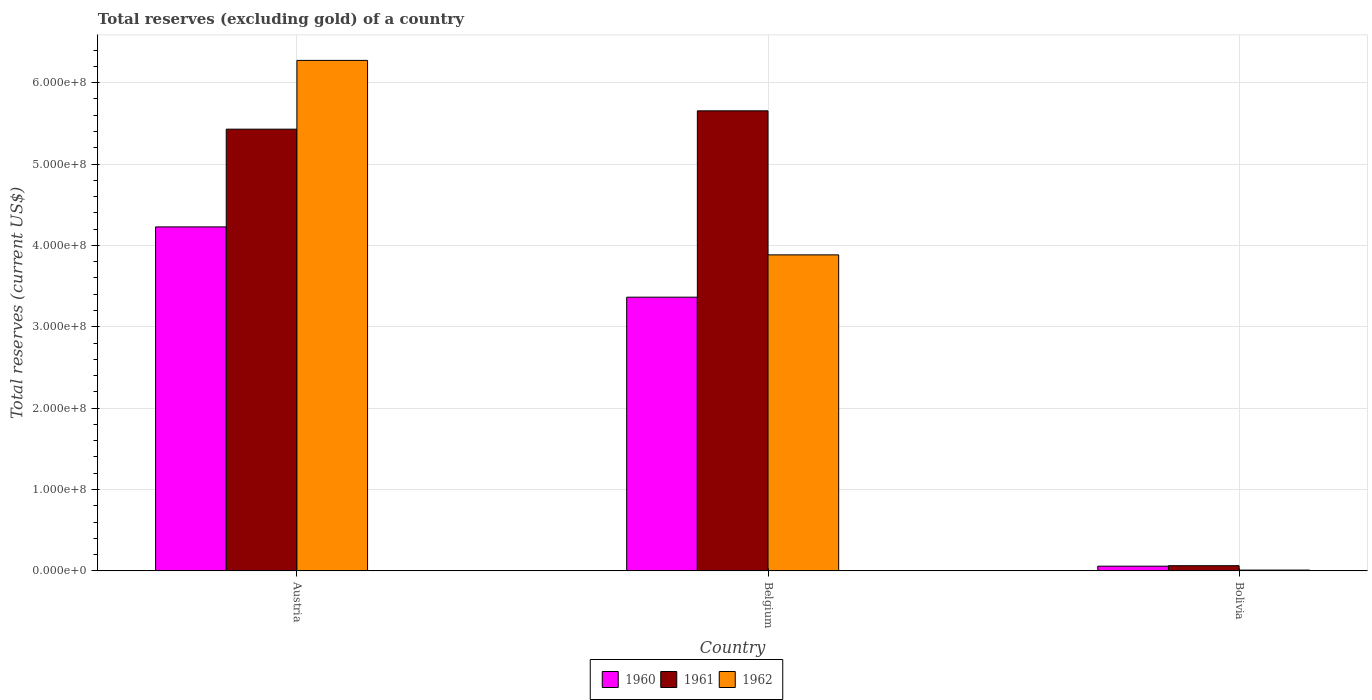How many different coloured bars are there?
Provide a short and direct response. 3. In how many cases, is the number of bars for a given country not equal to the number of legend labels?
Make the answer very short. 0. What is the total reserves (excluding gold) in 1960 in Bolivia?
Ensure brevity in your answer.  5.80e+06. Across all countries, what is the maximum total reserves (excluding gold) in 1960?
Provide a succinct answer. 4.23e+08. Across all countries, what is the minimum total reserves (excluding gold) in 1960?
Your answer should be very brief. 5.80e+06. In which country was the total reserves (excluding gold) in 1961 maximum?
Keep it short and to the point. Belgium. What is the total total reserves (excluding gold) in 1961 in the graph?
Make the answer very short. 1.11e+09. What is the difference between the total reserves (excluding gold) in 1961 in Austria and that in Belgium?
Your response must be concise. -2.25e+07. What is the difference between the total reserves (excluding gold) in 1961 in Bolivia and the total reserves (excluding gold) in 1962 in Belgium?
Keep it short and to the point. -3.82e+08. What is the average total reserves (excluding gold) in 1961 per country?
Offer a terse response. 3.72e+08. What is the difference between the total reserves (excluding gold) of/in 1960 and total reserves (excluding gold) of/in 1961 in Austria?
Keep it short and to the point. -1.20e+08. In how many countries, is the total reserves (excluding gold) in 1961 greater than 100000000 US$?
Offer a terse response. 2. What is the ratio of the total reserves (excluding gold) in 1962 in Austria to that in Bolivia?
Make the answer very short. 627.38. Is the total reserves (excluding gold) in 1960 in Belgium less than that in Bolivia?
Offer a terse response. No. What is the difference between the highest and the second highest total reserves (excluding gold) in 1961?
Offer a terse response. -5.36e+08. What is the difference between the highest and the lowest total reserves (excluding gold) in 1962?
Offer a very short reply. 6.26e+08. Are all the bars in the graph horizontal?
Ensure brevity in your answer.  No. What is the difference between two consecutive major ticks on the Y-axis?
Offer a very short reply. 1.00e+08. Where does the legend appear in the graph?
Offer a terse response. Bottom center. How many legend labels are there?
Ensure brevity in your answer.  3. What is the title of the graph?
Ensure brevity in your answer.  Total reserves (excluding gold) of a country. What is the label or title of the Y-axis?
Offer a very short reply. Total reserves (current US$). What is the Total reserves (current US$) in 1960 in Austria?
Keep it short and to the point. 4.23e+08. What is the Total reserves (current US$) in 1961 in Austria?
Provide a succinct answer. 5.43e+08. What is the Total reserves (current US$) in 1962 in Austria?
Ensure brevity in your answer.  6.27e+08. What is the Total reserves (current US$) in 1960 in Belgium?
Offer a terse response. 3.36e+08. What is the Total reserves (current US$) in 1961 in Belgium?
Provide a short and direct response. 5.65e+08. What is the Total reserves (current US$) of 1962 in Belgium?
Your answer should be compact. 3.88e+08. What is the Total reserves (current US$) of 1960 in Bolivia?
Your answer should be compact. 5.80e+06. What is the Total reserves (current US$) of 1961 in Bolivia?
Offer a very short reply. 6.40e+06. Across all countries, what is the maximum Total reserves (current US$) of 1960?
Give a very brief answer. 4.23e+08. Across all countries, what is the maximum Total reserves (current US$) in 1961?
Ensure brevity in your answer.  5.65e+08. Across all countries, what is the maximum Total reserves (current US$) in 1962?
Offer a very short reply. 6.27e+08. Across all countries, what is the minimum Total reserves (current US$) of 1960?
Your answer should be very brief. 5.80e+06. Across all countries, what is the minimum Total reserves (current US$) of 1961?
Make the answer very short. 6.40e+06. What is the total Total reserves (current US$) of 1960 in the graph?
Offer a very short reply. 7.65e+08. What is the total Total reserves (current US$) of 1961 in the graph?
Your response must be concise. 1.11e+09. What is the total Total reserves (current US$) of 1962 in the graph?
Make the answer very short. 1.02e+09. What is the difference between the Total reserves (current US$) in 1960 in Austria and that in Belgium?
Your answer should be very brief. 8.64e+07. What is the difference between the Total reserves (current US$) in 1961 in Austria and that in Belgium?
Provide a succinct answer. -2.25e+07. What is the difference between the Total reserves (current US$) of 1962 in Austria and that in Belgium?
Offer a terse response. 2.39e+08. What is the difference between the Total reserves (current US$) in 1960 in Austria and that in Bolivia?
Your answer should be very brief. 4.17e+08. What is the difference between the Total reserves (current US$) of 1961 in Austria and that in Bolivia?
Make the answer very short. 5.36e+08. What is the difference between the Total reserves (current US$) in 1962 in Austria and that in Bolivia?
Your response must be concise. 6.26e+08. What is the difference between the Total reserves (current US$) in 1960 in Belgium and that in Bolivia?
Make the answer very short. 3.31e+08. What is the difference between the Total reserves (current US$) of 1961 in Belgium and that in Bolivia?
Provide a succinct answer. 5.59e+08. What is the difference between the Total reserves (current US$) in 1962 in Belgium and that in Bolivia?
Give a very brief answer. 3.87e+08. What is the difference between the Total reserves (current US$) in 1960 in Austria and the Total reserves (current US$) in 1961 in Belgium?
Make the answer very short. -1.43e+08. What is the difference between the Total reserves (current US$) in 1960 in Austria and the Total reserves (current US$) in 1962 in Belgium?
Give a very brief answer. 3.44e+07. What is the difference between the Total reserves (current US$) of 1961 in Austria and the Total reserves (current US$) of 1962 in Belgium?
Give a very brief answer. 1.54e+08. What is the difference between the Total reserves (current US$) in 1960 in Austria and the Total reserves (current US$) in 1961 in Bolivia?
Provide a succinct answer. 4.16e+08. What is the difference between the Total reserves (current US$) in 1960 in Austria and the Total reserves (current US$) in 1962 in Bolivia?
Your response must be concise. 4.22e+08. What is the difference between the Total reserves (current US$) of 1961 in Austria and the Total reserves (current US$) of 1962 in Bolivia?
Provide a succinct answer. 5.42e+08. What is the difference between the Total reserves (current US$) in 1960 in Belgium and the Total reserves (current US$) in 1961 in Bolivia?
Give a very brief answer. 3.30e+08. What is the difference between the Total reserves (current US$) in 1960 in Belgium and the Total reserves (current US$) in 1962 in Bolivia?
Offer a very short reply. 3.35e+08. What is the difference between the Total reserves (current US$) in 1961 in Belgium and the Total reserves (current US$) in 1962 in Bolivia?
Make the answer very short. 5.64e+08. What is the average Total reserves (current US$) of 1960 per country?
Provide a succinct answer. 2.55e+08. What is the average Total reserves (current US$) in 1961 per country?
Your answer should be very brief. 3.72e+08. What is the average Total reserves (current US$) of 1962 per country?
Your answer should be very brief. 3.39e+08. What is the difference between the Total reserves (current US$) in 1960 and Total reserves (current US$) in 1961 in Austria?
Your answer should be compact. -1.20e+08. What is the difference between the Total reserves (current US$) of 1960 and Total reserves (current US$) of 1962 in Austria?
Offer a very short reply. -2.05e+08. What is the difference between the Total reserves (current US$) of 1961 and Total reserves (current US$) of 1962 in Austria?
Your answer should be very brief. -8.45e+07. What is the difference between the Total reserves (current US$) of 1960 and Total reserves (current US$) of 1961 in Belgium?
Offer a terse response. -2.29e+08. What is the difference between the Total reserves (current US$) of 1960 and Total reserves (current US$) of 1962 in Belgium?
Keep it short and to the point. -5.20e+07. What is the difference between the Total reserves (current US$) of 1961 and Total reserves (current US$) of 1962 in Belgium?
Ensure brevity in your answer.  1.77e+08. What is the difference between the Total reserves (current US$) of 1960 and Total reserves (current US$) of 1961 in Bolivia?
Provide a short and direct response. -6.00e+05. What is the difference between the Total reserves (current US$) of 1960 and Total reserves (current US$) of 1962 in Bolivia?
Give a very brief answer. 4.80e+06. What is the difference between the Total reserves (current US$) in 1961 and Total reserves (current US$) in 1962 in Bolivia?
Offer a very short reply. 5.40e+06. What is the ratio of the Total reserves (current US$) in 1960 in Austria to that in Belgium?
Keep it short and to the point. 1.26. What is the ratio of the Total reserves (current US$) of 1961 in Austria to that in Belgium?
Ensure brevity in your answer.  0.96. What is the ratio of the Total reserves (current US$) in 1962 in Austria to that in Belgium?
Your answer should be very brief. 1.62. What is the ratio of the Total reserves (current US$) in 1960 in Austria to that in Bolivia?
Give a very brief answer. 72.89. What is the ratio of the Total reserves (current US$) of 1961 in Austria to that in Bolivia?
Make the answer very short. 84.82. What is the ratio of the Total reserves (current US$) in 1962 in Austria to that in Bolivia?
Offer a very short reply. 627.38. What is the ratio of the Total reserves (current US$) in 1960 in Belgium to that in Bolivia?
Keep it short and to the point. 58. What is the ratio of the Total reserves (current US$) of 1961 in Belgium to that in Bolivia?
Give a very brief answer. 88.34. What is the ratio of the Total reserves (current US$) of 1962 in Belgium to that in Bolivia?
Offer a very short reply. 388.39. What is the difference between the highest and the second highest Total reserves (current US$) of 1960?
Ensure brevity in your answer.  8.64e+07. What is the difference between the highest and the second highest Total reserves (current US$) of 1961?
Offer a very short reply. 2.25e+07. What is the difference between the highest and the second highest Total reserves (current US$) in 1962?
Provide a succinct answer. 2.39e+08. What is the difference between the highest and the lowest Total reserves (current US$) of 1960?
Keep it short and to the point. 4.17e+08. What is the difference between the highest and the lowest Total reserves (current US$) of 1961?
Keep it short and to the point. 5.59e+08. What is the difference between the highest and the lowest Total reserves (current US$) in 1962?
Ensure brevity in your answer.  6.26e+08. 